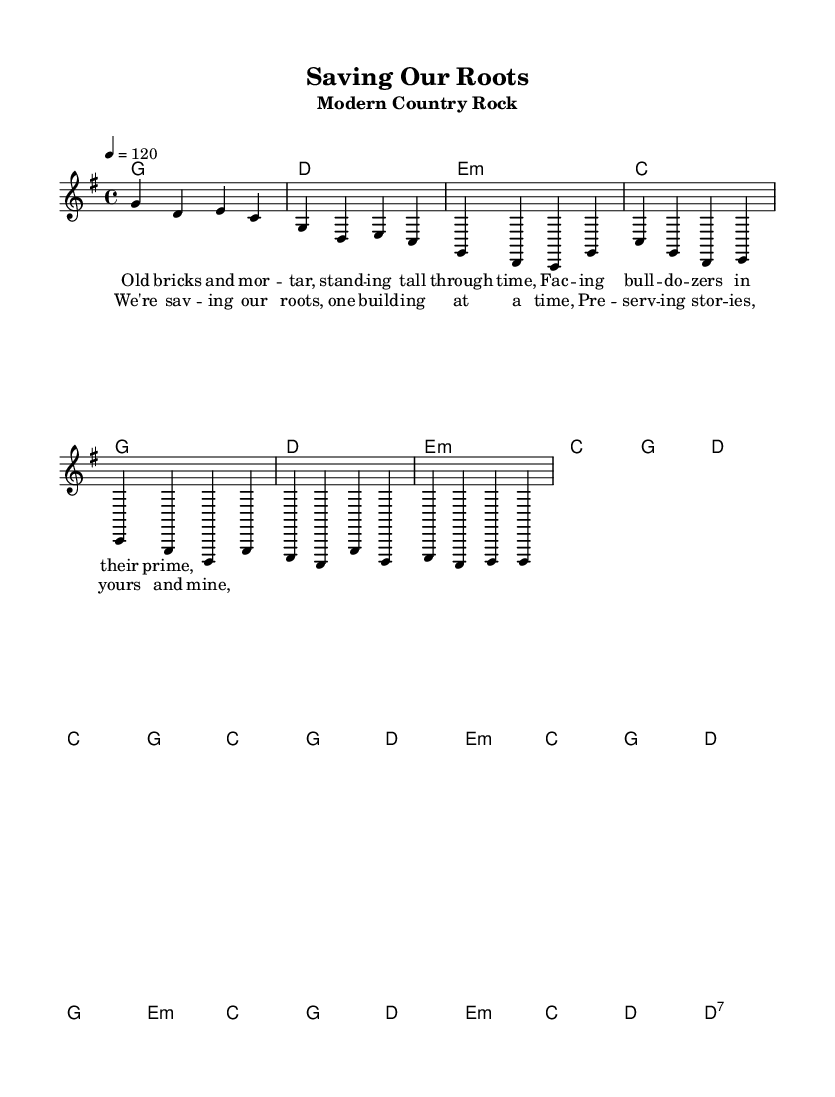What is the key signature of this music? The key signature is G major, which has one sharp (F#). This can be identified by looking at the key signature placement at the beginning of the score.
Answer: G major What is the time signature of the piece? The time signature is 4/4, meaning there are four beats in a measure and the quarter note gets one beat. This is usually indicated at the beginning of the score right after the clef and key signature.
Answer: 4/4 What is the tempo marking for this piece? The tempo marking is 120 beats per minute, as indicated by the notation of "4 = 120" at the top of the score. This tells performers how fast to play the piece.
Answer: 120 How many measures are in the chorus section? The chorus consists of eight measures. This includes counting each segment of music written before a bar line in the chorus lyrics.
Answer: Eight Which chord comes first in the bridge? The first chord in the bridge is E minor, shown at the beginning of the bridge section in the chord progression.
Answer: E minor What lyrical theme does the verse address? The verse discusses the theme of historic preservation in relation to aging buildings, as evidenced by the lyrics referring to "Old bricks and mortar." This shows a direct connection to the challenges of maintaining historic structures.
Answer: Historic preservation What type of musical form does this song exhibit? The song exhibits a verse-chorus structure, as it includes distinct sections labeled verse and chorus that are repeated throughout. This is a common structure in country rock music.
Answer: Verse-chorus 